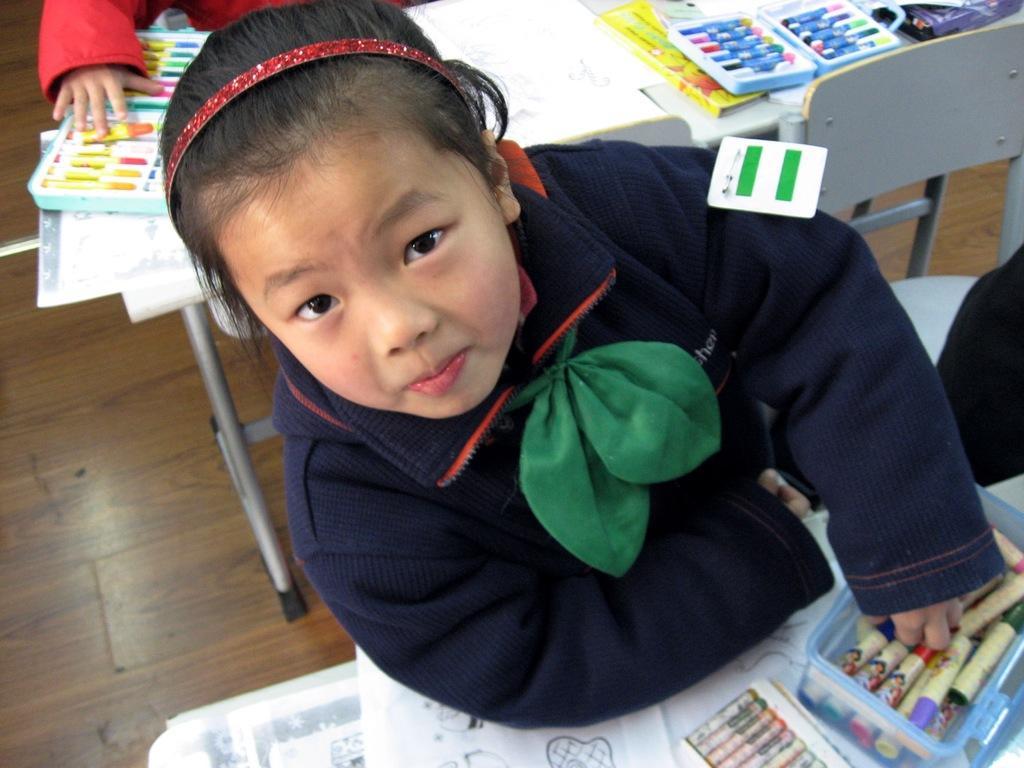Could you give a brief overview of what you see in this image? In this picture we can see two kids and tables, there are some papers, drawing pencils and boxes present on these tables, at the bottom there is floor, on the right side there is a chair. 